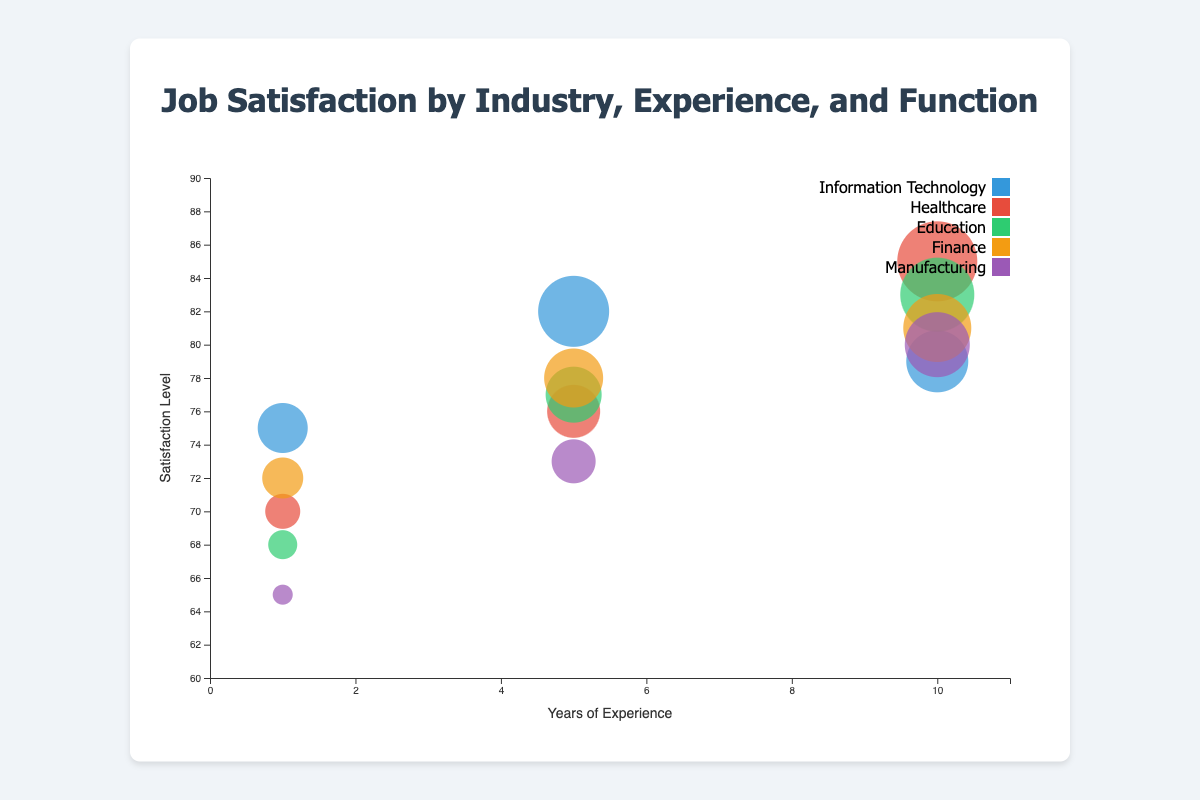What is the job satisfaction level of a Software Developer with 1 year of experience in the Information Technology industry? Locate the bubble that corresponds to a Software Developer with 1 year of experience in the Information Technology industry, noted by color coding and position on the x-axis and y-axis.
Answer: 75 How many job functions are represented in the Healthcare industry? Count the distinct bubbles within the Healthcare industry indicated by color. Each bubble represents a unique job function.
Answer: 3 Which industry has the highest job satisfaction level and what is the job function and years of experience for that data point? The highest satisfaction level bubble is found by observing the y-axis. The highest bubble is in the Healthcare industry, which represents the job function of Surgeon with 10 years of experience.
Answer: Healthcare, Surgeon, 10 years Compare the satisfaction levels between a Project Manager in Information Technology with 5 years of experience and a School Principal in Education with the same experience. Locate the respective bubbles in Information Technology and Education with 5 years of experience and compare their y-axis values.
Answer: Project Manager: 82, School Principal: 77 What industry shows the overall highest variation in job satisfaction levels based on the bubbles’ positions? The industry with the greatest spread in y-axis positions represents the highest variation. Healthcare and Education show significant ranges (Healthcare: 70-85, Education: 68-83).
Answer: Healthcare and Education On average, what is the job satisfaction level across all industries for positions with 10 years of experience? Identify and sum the satisfaction levels for all bubbles with 10 years of experience, then divide by the number of such data points: (79 + 85 + 83 + 81 + 80) / 5 = 81.6
Answer: 81.6 Compare the job satisfaction levels of an Accountant with 1 year of experience in Finance and a Teacher with 1 year of experience in Education. Find the respective bubbles for each job function and experience, then compare their satisfaction levels.
Answer: Accountant: 72, Teacher: 68 What trend can be observed in satisfaction levels for the Manufacturing industry as years of experience increase? Observe the bubbles in the Manufacturing industry. Satisfaction levels increase from Production Worker (65) to Production Manager (73) to Operations Director (80) with increasing years of experience.
Answer: Increasing trend Which industry has the least job satisfaction level and what is the job function and years of experience for that data point? Identify the lowest satisfaction level bubble by observing the y-axis. It’s in the Manufacturing industry, representing the job function of Production Worker with 1 year of experience.
Answer: Manufacturing, Production Worker, 1 year 